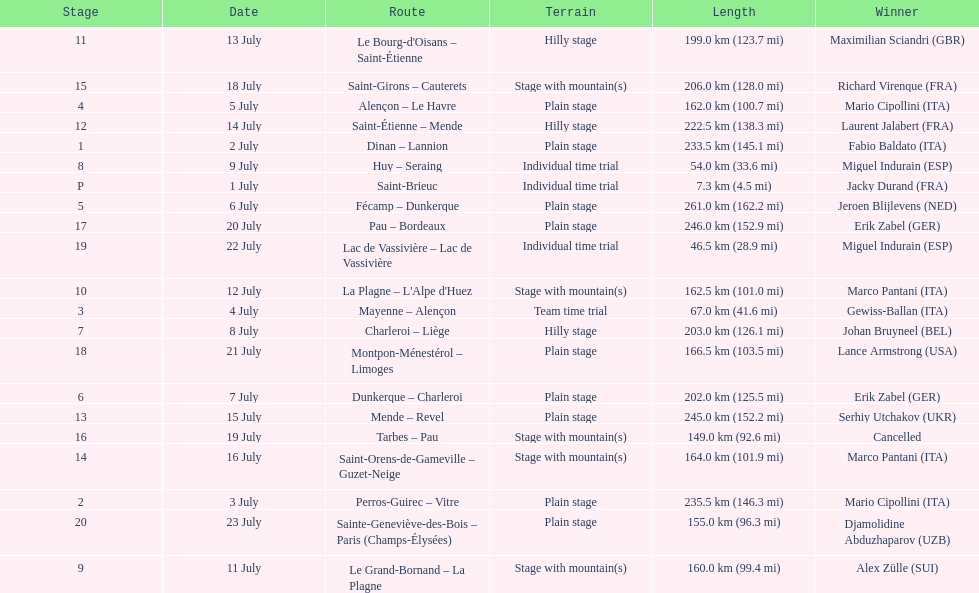After lance armstrong, who led next in the 1995 tour de france? Miguel Indurain. 